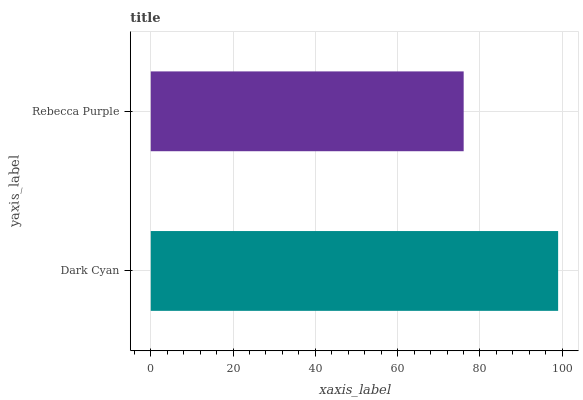Is Rebecca Purple the minimum?
Answer yes or no. Yes. Is Dark Cyan the maximum?
Answer yes or no. Yes. Is Rebecca Purple the maximum?
Answer yes or no. No. Is Dark Cyan greater than Rebecca Purple?
Answer yes or no. Yes. Is Rebecca Purple less than Dark Cyan?
Answer yes or no. Yes. Is Rebecca Purple greater than Dark Cyan?
Answer yes or no. No. Is Dark Cyan less than Rebecca Purple?
Answer yes or no. No. Is Dark Cyan the high median?
Answer yes or no. Yes. Is Rebecca Purple the low median?
Answer yes or no. Yes. Is Rebecca Purple the high median?
Answer yes or no. No. Is Dark Cyan the low median?
Answer yes or no. No. 